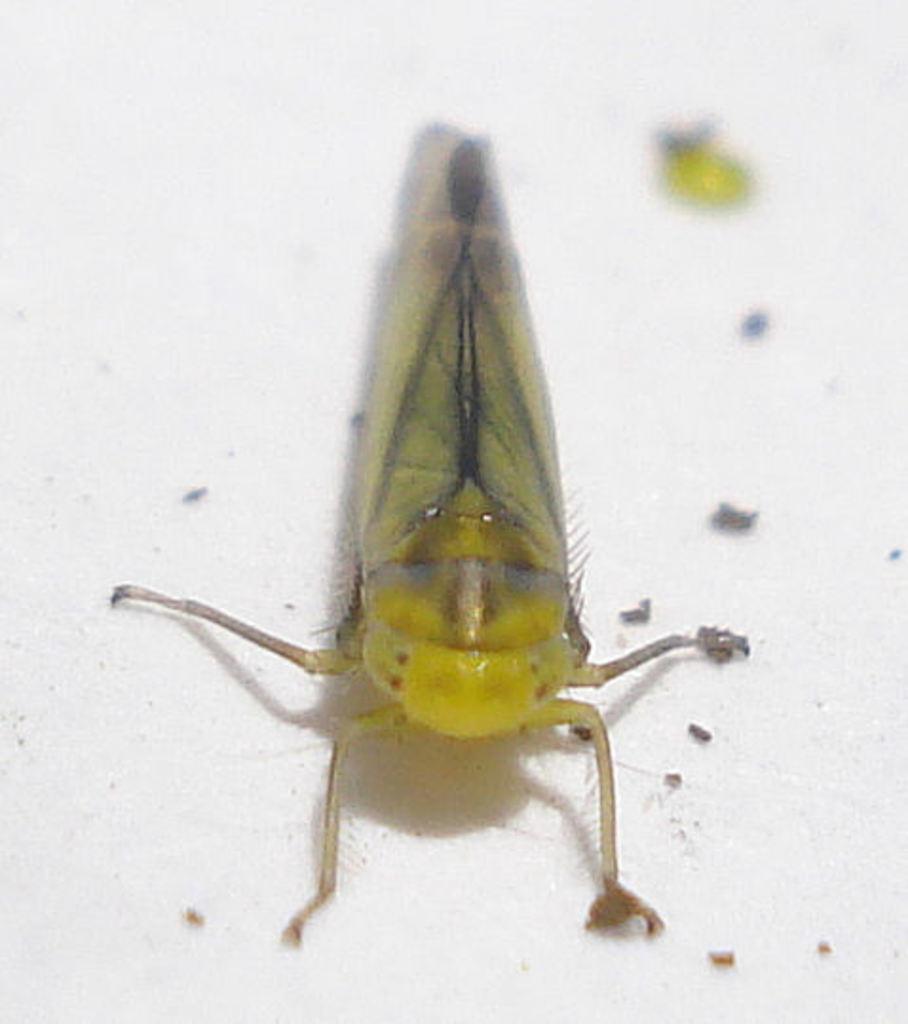Could you give a brief overview of what you see in this image? In this image, we can see an insect on the surface. 